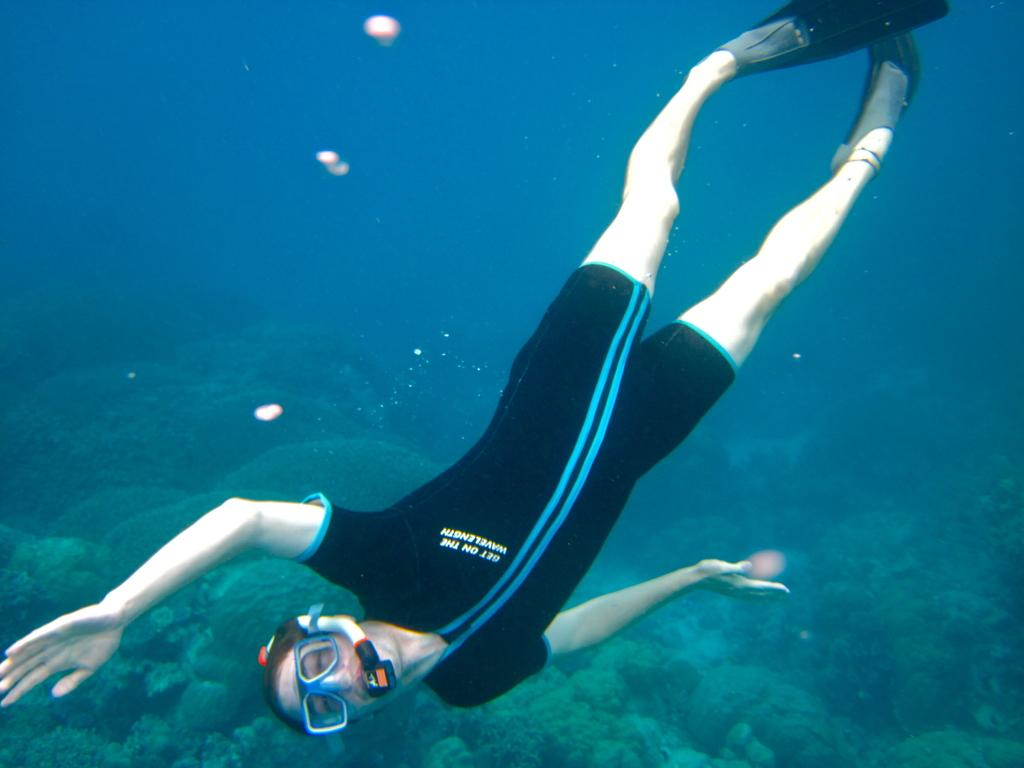What is the person in the image doing? The person is swimming in the water. Can you describe the person's appearance? The person is wearing glasses and a black color suit. What else can be seen in the image besides the person swimming? There are other objects visible in the image, as well as stones and bubbles in the background. What type of bone can be seen in the person's hand in the image? There is no bone present in the person's hand or anywhere else in the image. 